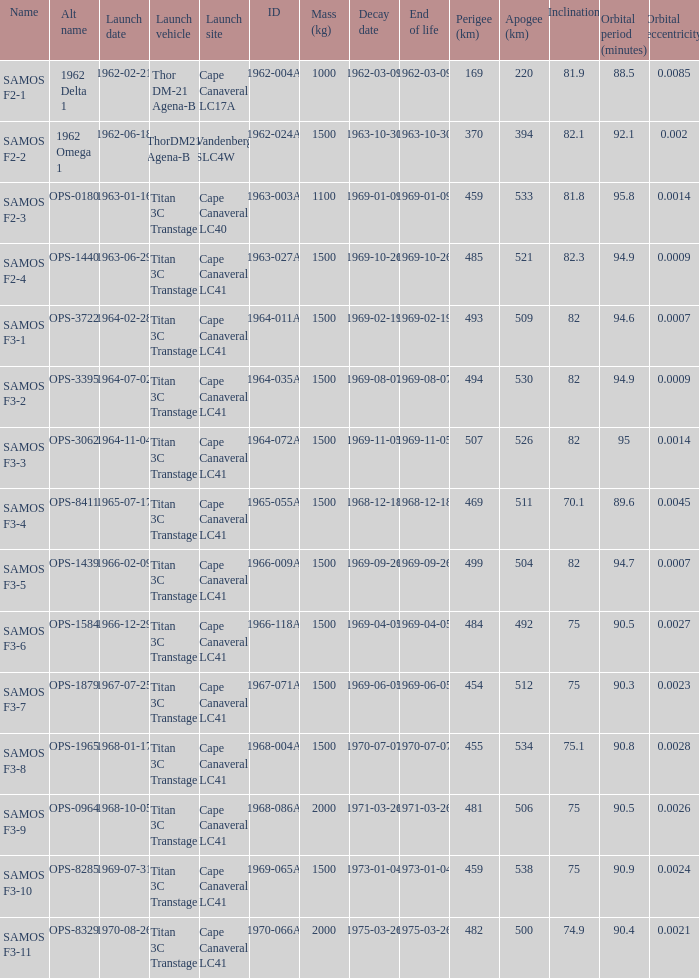What is the maximum apogee for samos f3-3? 526.0. 